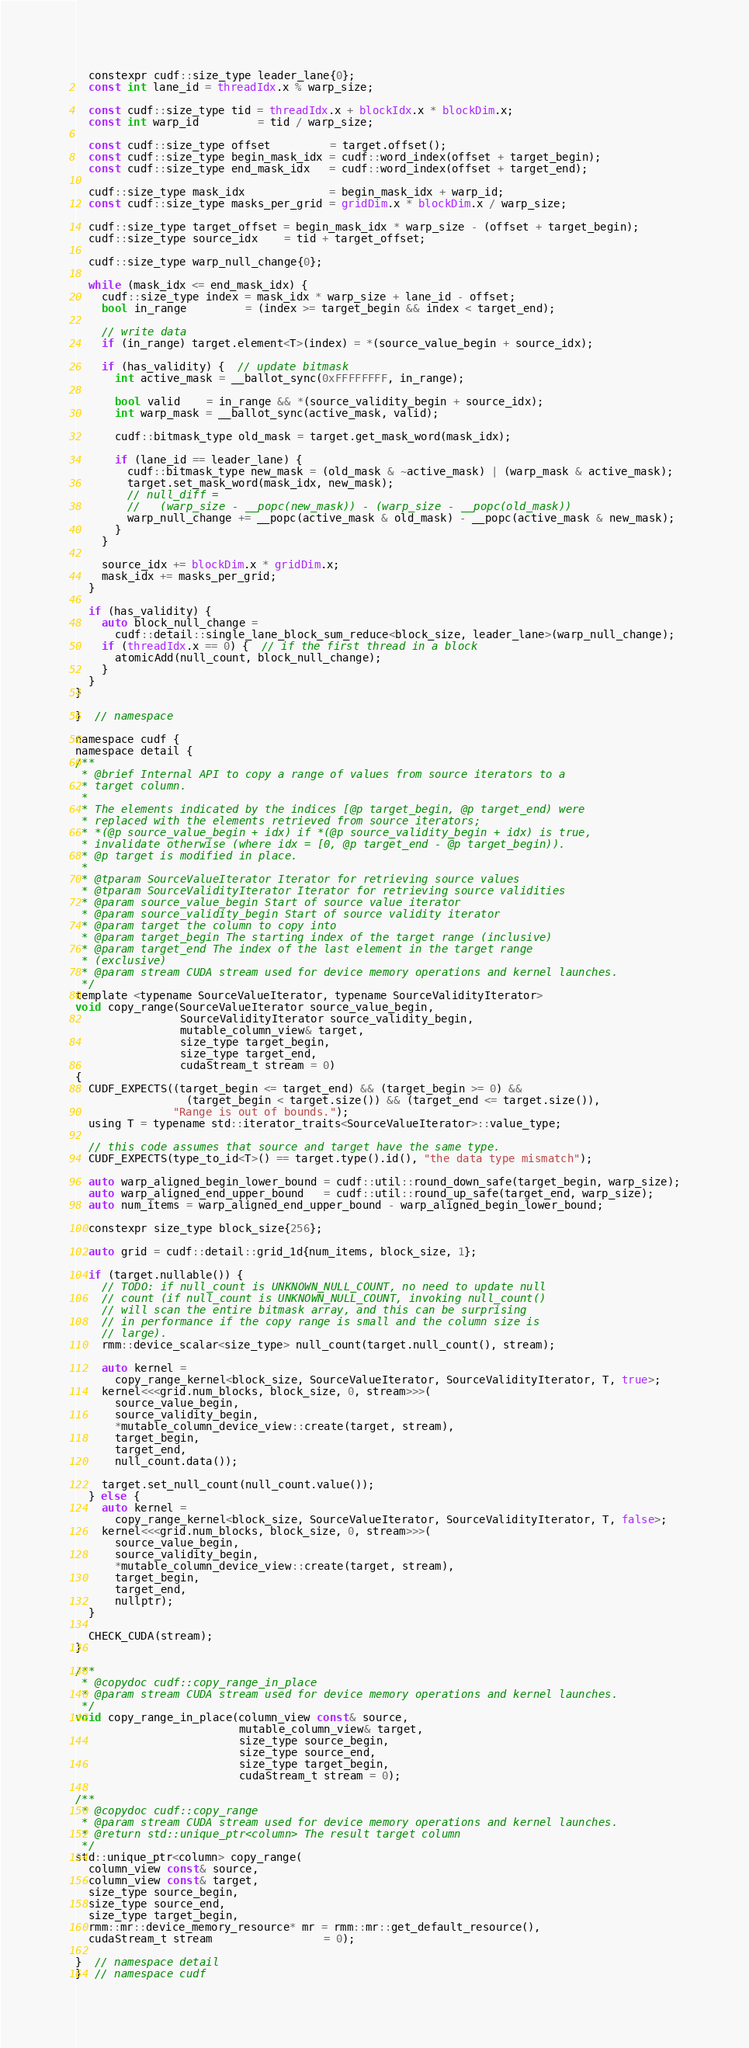<code> <loc_0><loc_0><loc_500><loc_500><_Cuda_>
  constexpr cudf::size_type leader_lane{0};
  const int lane_id = threadIdx.x % warp_size;

  const cudf::size_type tid = threadIdx.x + blockIdx.x * blockDim.x;
  const int warp_id         = tid / warp_size;

  const cudf::size_type offset         = target.offset();
  const cudf::size_type begin_mask_idx = cudf::word_index(offset + target_begin);
  const cudf::size_type end_mask_idx   = cudf::word_index(offset + target_end);

  cudf::size_type mask_idx             = begin_mask_idx + warp_id;
  const cudf::size_type masks_per_grid = gridDim.x * blockDim.x / warp_size;

  cudf::size_type target_offset = begin_mask_idx * warp_size - (offset + target_begin);
  cudf::size_type source_idx    = tid + target_offset;

  cudf::size_type warp_null_change{0};

  while (mask_idx <= end_mask_idx) {
    cudf::size_type index = mask_idx * warp_size + lane_id - offset;
    bool in_range         = (index >= target_begin && index < target_end);

    // write data
    if (in_range) target.element<T>(index) = *(source_value_begin + source_idx);

    if (has_validity) {  // update bitmask
      int active_mask = __ballot_sync(0xFFFFFFFF, in_range);

      bool valid    = in_range && *(source_validity_begin + source_idx);
      int warp_mask = __ballot_sync(active_mask, valid);

      cudf::bitmask_type old_mask = target.get_mask_word(mask_idx);

      if (lane_id == leader_lane) {
        cudf::bitmask_type new_mask = (old_mask & ~active_mask) | (warp_mask & active_mask);
        target.set_mask_word(mask_idx, new_mask);
        // null_diff =
        //   (warp_size - __popc(new_mask)) - (warp_size - __popc(old_mask))
        warp_null_change += __popc(active_mask & old_mask) - __popc(active_mask & new_mask);
      }
    }

    source_idx += blockDim.x * gridDim.x;
    mask_idx += masks_per_grid;
  }

  if (has_validity) {
    auto block_null_change =
      cudf::detail::single_lane_block_sum_reduce<block_size, leader_lane>(warp_null_change);
    if (threadIdx.x == 0) {  // if the first thread in a block
      atomicAdd(null_count, block_null_change);
    }
  }
}

}  // namespace

namespace cudf {
namespace detail {
/**
 * @brief Internal API to copy a range of values from source iterators to a
 * target column.
 *
 * The elements indicated by the indices [@p target_begin, @p target_end) were
 * replaced with the elements retrieved from source iterators;
 * *(@p source_value_begin + idx) if *(@p source_validity_begin + idx) is true,
 * invalidate otherwise (where idx = [0, @p target_end - @p target_begin)).
 * @p target is modified in place.
 *
 * @tparam SourceValueIterator Iterator for retrieving source values
 * @tparam SourceValidityIterator Iterator for retrieving source validities
 * @param source_value_begin Start of source value iterator
 * @param source_validity_begin Start of source validity iterator
 * @param target the column to copy into
 * @param target_begin The starting index of the target range (inclusive)
 * @param target_end The index of the last element in the target range
 * (exclusive)
 * @param stream CUDA stream used for device memory operations and kernel launches.
 */
template <typename SourceValueIterator, typename SourceValidityIterator>
void copy_range(SourceValueIterator source_value_begin,
                SourceValidityIterator source_validity_begin,
                mutable_column_view& target,
                size_type target_begin,
                size_type target_end,
                cudaStream_t stream = 0)
{
  CUDF_EXPECTS((target_begin <= target_end) && (target_begin >= 0) &&
                 (target_begin < target.size()) && (target_end <= target.size()),
               "Range is out of bounds.");
  using T = typename std::iterator_traits<SourceValueIterator>::value_type;

  // this code assumes that source and target have the same type.
  CUDF_EXPECTS(type_to_id<T>() == target.type().id(), "the data type mismatch");

  auto warp_aligned_begin_lower_bound = cudf::util::round_down_safe(target_begin, warp_size);
  auto warp_aligned_end_upper_bound   = cudf::util::round_up_safe(target_end, warp_size);
  auto num_items = warp_aligned_end_upper_bound - warp_aligned_begin_lower_bound;

  constexpr size_type block_size{256};

  auto grid = cudf::detail::grid_1d{num_items, block_size, 1};

  if (target.nullable()) {
    // TODO: if null_count is UNKNOWN_NULL_COUNT, no need to update null
    // count (if null_count is UNKNOWN_NULL_COUNT, invoking null_count()
    // will scan the entire bitmask array, and this can be surprising
    // in performance if the copy range is small and the column size is
    // large).
    rmm::device_scalar<size_type> null_count(target.null_count(), stream);

    auto kernel =
      copy_range_kernel<block_size, SourceValueIterator, SourceValidityIterator, T, true>;
    kernel<<<grid.num_blocks, block_size, 0, stream>>>(
      source_value_begin,
      source_validity_begin,
      *mutable_column_device_view::create(target, stream),
      target_begin,
      target_end,
      null_count.data());

    target.set_null_count(null_count.value());
  } else {
    auto kernel =
      copy_range_kernel<block_size, SourceValueIterator, SourceValidityIterator, T, false>;
    kernel<<<grid.num_blocks, block_size, 0, stream>>>(
      source_value_begin,
      source_validity_begin,
      *mutable_column_device_view::create(target, stream),
      target_begin,
      target_end,
      nullptr);
  }

  CHECK_CUDA(stream);
}

/**
 * @copydoc cudf::copy_range_in_place
 * @param stream CUDA stream used for device memory operations and kernel launches.
 */
void copy_range_in_place(column_view const& source,
                         mutable_column_view& target,
                         size_type source_begin,
                         size_type source_end,
                         size_type target_begin,
                         cudaStream_t stream = 0);

/**
 * @copydoc cudf::copy_range
 * @param stream CUDA stream used for device memory operations and kernel launches.
 * @return std::unique_ptr<column> The result target column
 */
std::unique_ptr<column> copy_range(
  column_view const& source,
  column_view const& target,
  size_type source_begin,
  size_type source_end,
  size_type target_begin,
  rmm::mr::device_memory_resource* mr = rmm::mr::get_default_resource(),
  cudaStream_t stream                 = 0);

}  // namespace detail
}  // namespace cudf
</code> 